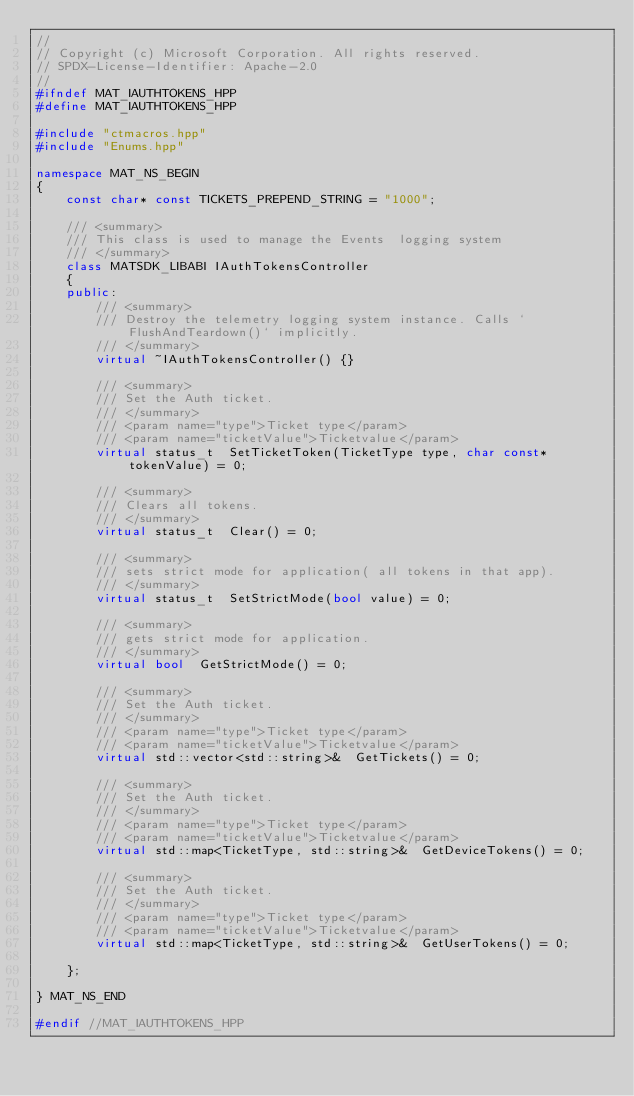<code> <loc_0><loc_0><loc_500><loc_500><_C++_>//
// Copyright (c) Microsoft Corporation. All rights reserved.
// SPDX-License-Identifier: Apache-2.0
//
#ifndef MAT_IAUTHTOKENS_HPP
#define MAT_IAUTHTOKENS_HPP

#include "ctmacros.hpp"
#include "Enums.hpp"

namespace MAT_NS_BEGIN
{
    const char* const TICKETS_PREPEND_STRING = "1000";

    /// <summary>
    /// This class is used to manage the Events  logging system
    /// </summary>
    class MATSDK_LIBABI IAuthTokensController
    {
    public:
        /// <summary>
        /// Destroy the telemetry logging system instance. Calls `FlushAndTeardown()` implicitly.
        /// </summary>
        virtual ~IAuthTokensController() {}

        /// <summary>
        /// Set the Auth ticket.
        /// </summary>
        /// <param name="type">Ticket type</param>
        /// <param name="ticketValue">Ticketvalue</param>
        virtual status_t  SetTicketToken(TicketType type, char const* tokenValue) = 0;

        /// <summary>
        /// Clears all tokens.
        /// </summary>
        virtual status_t  Clear() = 0;

        /// <summary>
        /// sets strict mode for application( all tokens in that app).
        /// </summary>
        virtual status_t  SetStrictMode(bool value) = 0;

        /// <summary>
        /// gets strict mode for application.
        /// </summary>
        virtual bool  GetStrictMode() = 0;

        /// <summary>
        /// Set the Auth ticket.
        /// </summary>
        /// <param name="type">Ticket type</param>
        /// <param name="ticketValue">Ticketvalue</param>
        virtual std::vector<std::string>&  GetTickets() = 0;

        /// <summary>
        /// Set the Auth ticket.
        /// </summary>
        /// <param name="type">Ticket type</param>
        /// <param name="ticketValue">Ticketvalue</param>
        virtual std::map<TicketType, std::string>&  GetDeviceTokens() = 0;

        /// <summary>
        /// Set the Auth ticket.
        /// </summary>
        /// <param name="type">Ticket type</param>
        /// <param name="ticketValue">Ticketvalue</param>
        virtual std::map<TicketType, std::string>&  GetUserTokens() = 0;

    };

} MAT_NS_END

#endif //MAT_IAUTHTOKENS_HPP
</code> 